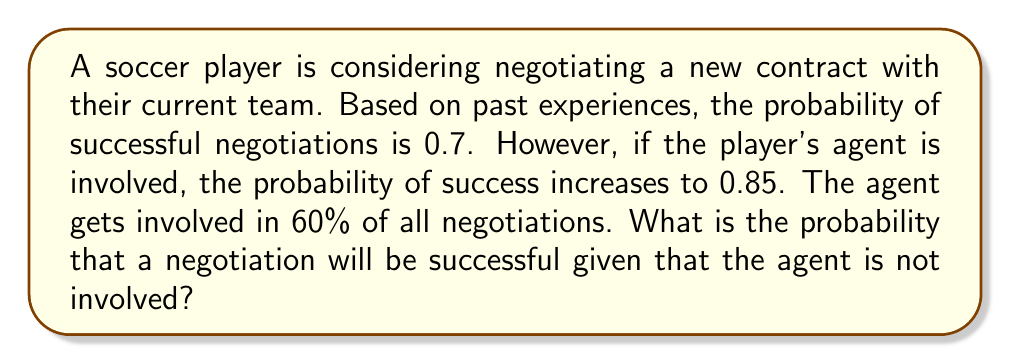Show me your answer to this math problem. Let's approach this problem using conditional probability. We'll define the following events:

S: Successful negotiation
A: Agent is involved

Given:
P(S) = 0.7 (overall probability of successful negotiation)
P(S|A) = 0.85 (probability of success given agent involvement)
P(A) = 0.6 (probability of agent involvement)

We need to find P(S|not A), which is the probability of success given the agent is not involved.

Step 1: Use the law of total probability to express P(S):
$$P(S) = P(S|A) \cdot P(A) + P(S|\text{not }A) \cdot P(\text{not }A)$$

Step 2: Substitute known values:
$$0.7 = 0.85 \cdot 0.6 + P(S|\text{not }A) \cdot (1 - 0.6)$$

Step 3: Simplify:
$$0.7 = 0.51 + P(S|\text{not }A) \cdot 0.4$$

Step 4: Solve for P(S|not A):
$$P(S|\text{not }A) \cdot 0.4 = 0.7 - 0.51 = 0.19$$
$$P(S|\text{not }A) = \frac{0.19}{0.4} = 0.475$$

Therefore, the probability of successful negotiations given that the agent is not involved is 0.475 or 47.5%.
Answer: $P(S|\text{not }A) = 0.475$ or 47.5% 